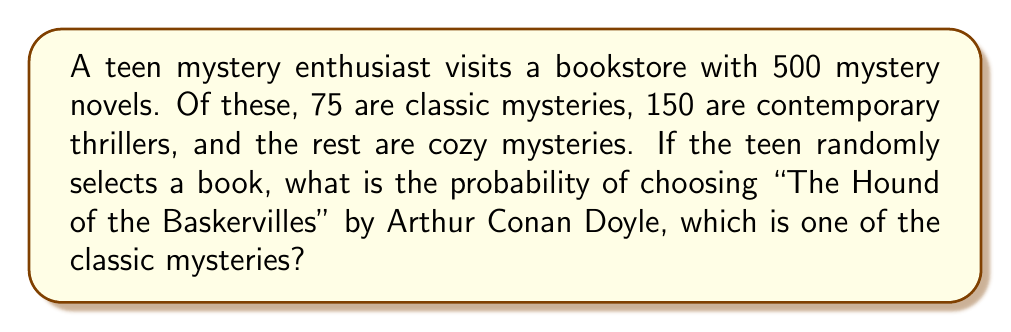Teach me how to tackle this problem. Let's approach this step-by-step:

1) First, we need to identify the total number of mystery novels and the number of classic mysteries:
   - Total mystery novels: 500
   - Classic mysteries: 75

2) We're looking for a specific book ("The Hound of the Baskervilles") within the classic mysteries category.

3) Assuming there's only one copy of "The Hound of the Baskervilles", it represents 1 book out of the 75 classic mysteries.

4) The probability of selecting this specific book is the number of favorable outcomes divided by the total number of possible outcomes:

   $$P(\text{The Hound of the Baskervilles}) = \frac{\text{Number of copies of the book}}{\text{Total number of mystery novels}}$$

5) Substituting the values:

   $$P(\text{The Hound of the Baskervilles}) = \frac{1}{500}$$

6) This can be simplified to:

   $$P(\text{The Hound of the Baskervilles}) = 0.002$$

7) We can also express this as a percentage:

   $$P(\text{The Hound of the Baskervilles}) = 0.2\%$$

Thus, the probability of randomly selecting "The Hound of the Baskervilles" from the entire collection of mystery novels is 0.002 or 0.2%.
Answer: $\frac{1}{500}$ or $0.002$ or $0.2\%$ 